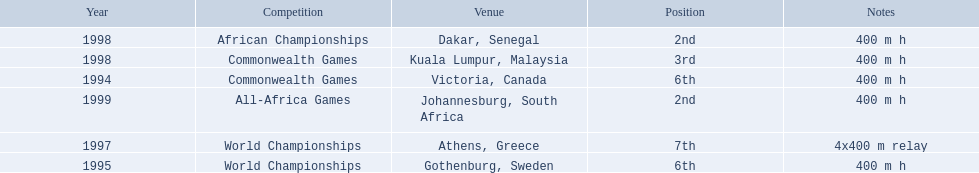Which year had the most competitions? 1998. 